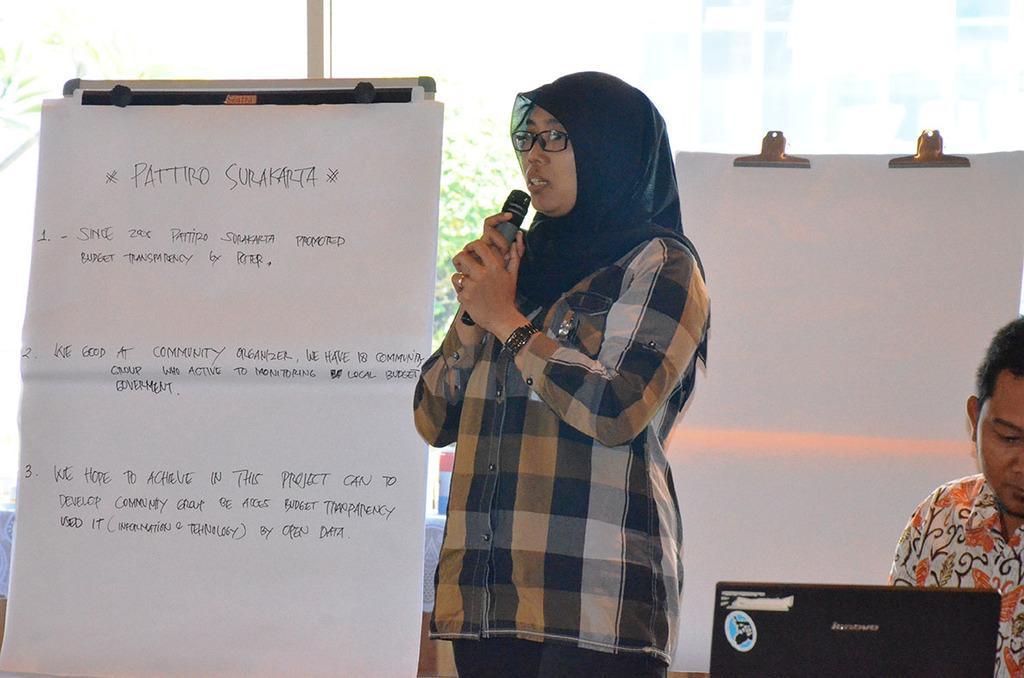Could you give a brief overview of what you see in this image? This is the woman standing. She is holding mike and speaking. This is the paper attached to the board. Here I can see another board with paper on it. This is the man sitting. This looks like a laptop which is black in color. At background this looks like a window. 